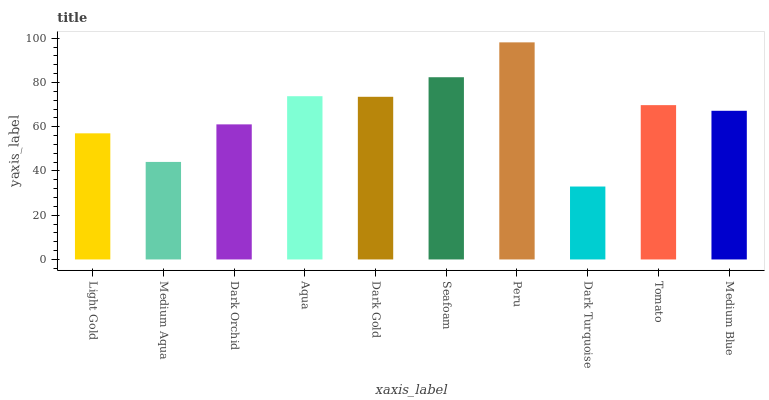Is Dark Turquoise the minimum?
Answer yes or no. Yes. Is Peru the maximum?
Answer yes or no. Yes. Is Medium Aqua the minimum?
Answer yes or no. No. Is Medium Aqua the maximum?
Answer yes or no. No. Is Light Gold greater than Medium Aqua?
Answer yes or no. Yes. Is Medium Aqua less than Light Gold?
Answer yes or no. Yes. Is Medium Aqua greater than Light Gold?
Answer yes or no. No. Is Light Gold less than Medium Aqua?
Answer yes or no. No. Is Tomato the high median?
Answer yes or no. Yes. Is Medium Blue the low median?
Answer yes or no. Yes. Is Light Gold the high median?
Answer yes or no. No. Is Dark Orchid the low median?
Answer yes or no. No. 